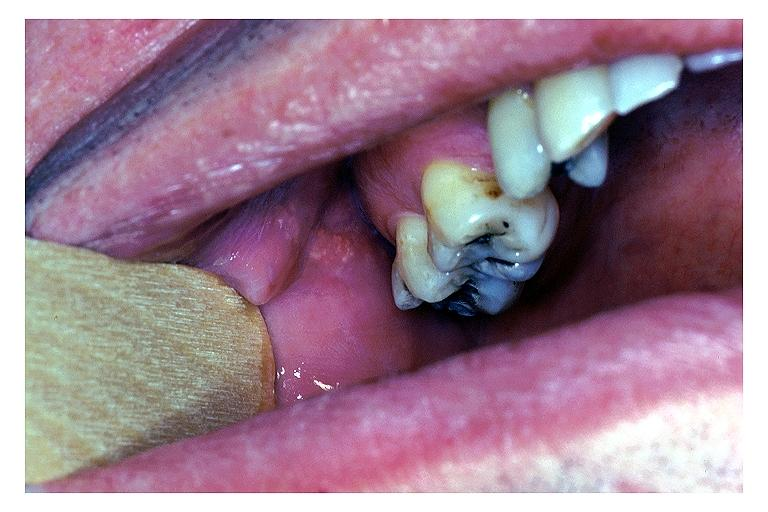s that present?
Answer the question using a single word or phrase. No 